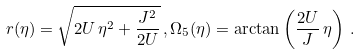<formula> <loc_0><loc_0><loc_500><loc_500>r ( \eta ) = \sqrt { 2 U \, \eta ^ { 2 } + \frac { J ^ { 2 } } { 2 U } } \, , \Omega _ { 5 } ( \eta ) = \arctan \left ( \frac { 2 U } { J } \, \eta \right ) \, .</formula> 